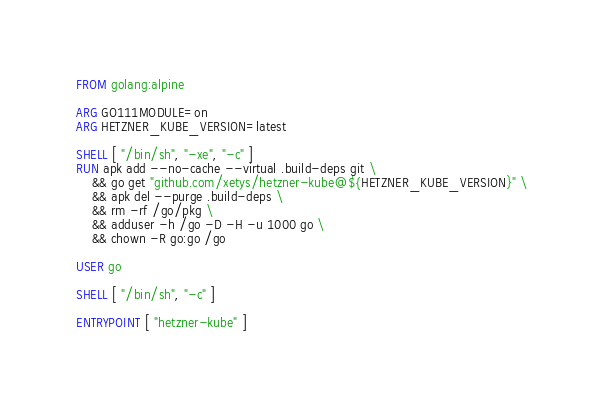Convert code to text. <code><loc_0><loc_0><loc_500><loc_500><_Dockerfile_>FROM golang:alpine

ARG GO111MODULE=on
ARG HETZNER_KUBE_VERSION=latest

SHELL [ "/bin/sh", "-xe", "-c" ]
RUN apk add --no-cache --virtual .build-deps git \
    && go get "github.com/xetys/hetzner-kube@${HETZNER_KUBE_VERSION}" \
    && apk del --purge .build-deps \
    && rm -rf /go/pkg \
    && adduser -h /go -D -H -u 1000 go \
    && chown -R go:go /go

USER go

SHELL [ "/bin/sh", "-c" ]

ENTRYPOINT [ "hetzner-kube" ]
</code> 